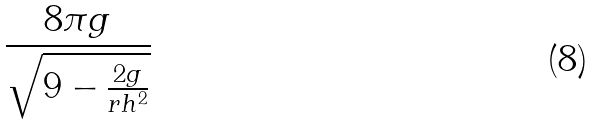Convert formula to latex. <formula><loc_0><loc_0><loc_500><loc_500>\frac { 8 \pi g } { \sqrt { 9 - \frac { 2 g } { r h ^ { 2 } } } }</formula> 